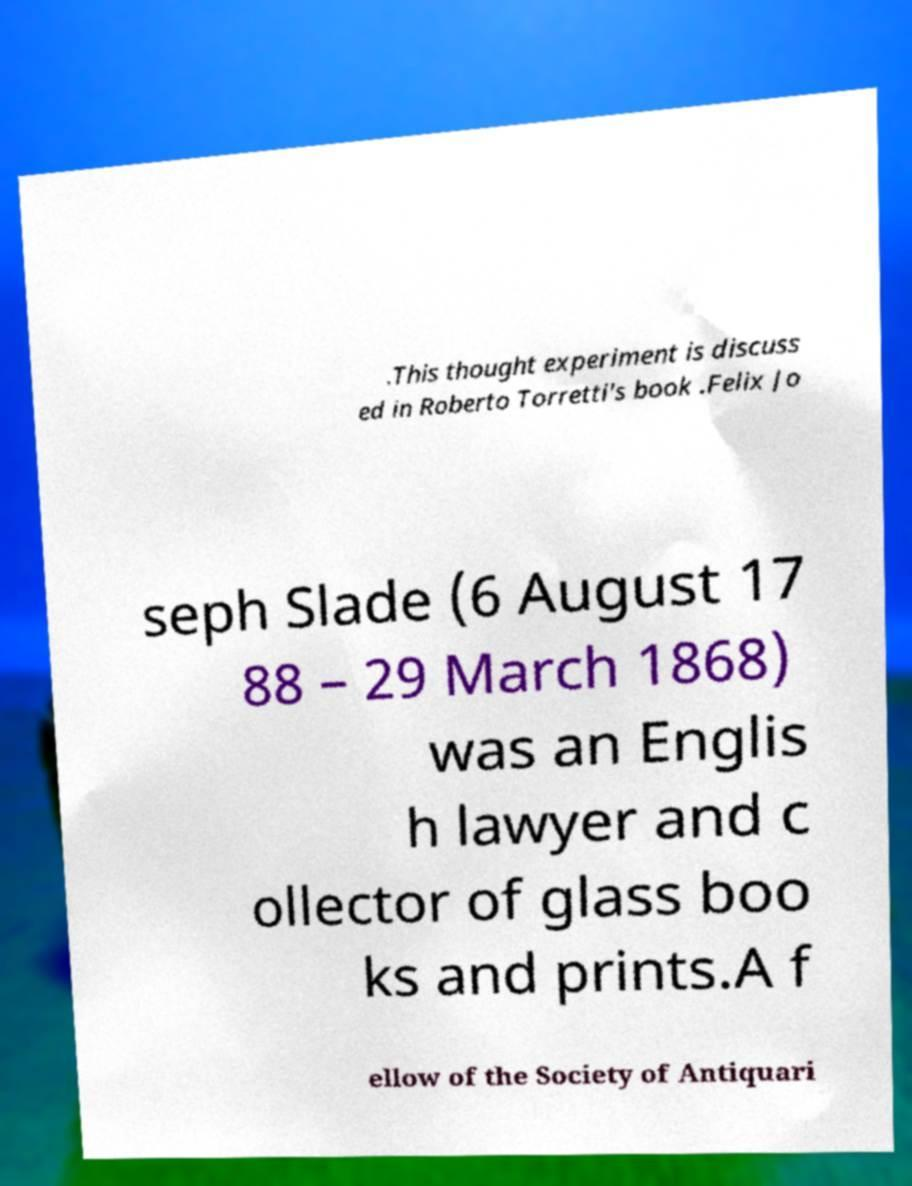Please read and relay the text visible in this image. What does it say? .This thought experiment is discuss ed in Roberto Torretti's book .Felix Jo seph Slade (6 August 17 88 – 29 March 1868) was an Englis h lawyer and c ollector of glass boo ks and prints.A f ellow of the Society of Antiquari 